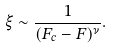Convert formula to latex. <formula><loc_0><loc_0><loc_500><loc_500>\xi \sim \frac { 1 } { ( F _ { c } - F ) ^ { \nu } } .</formula> 